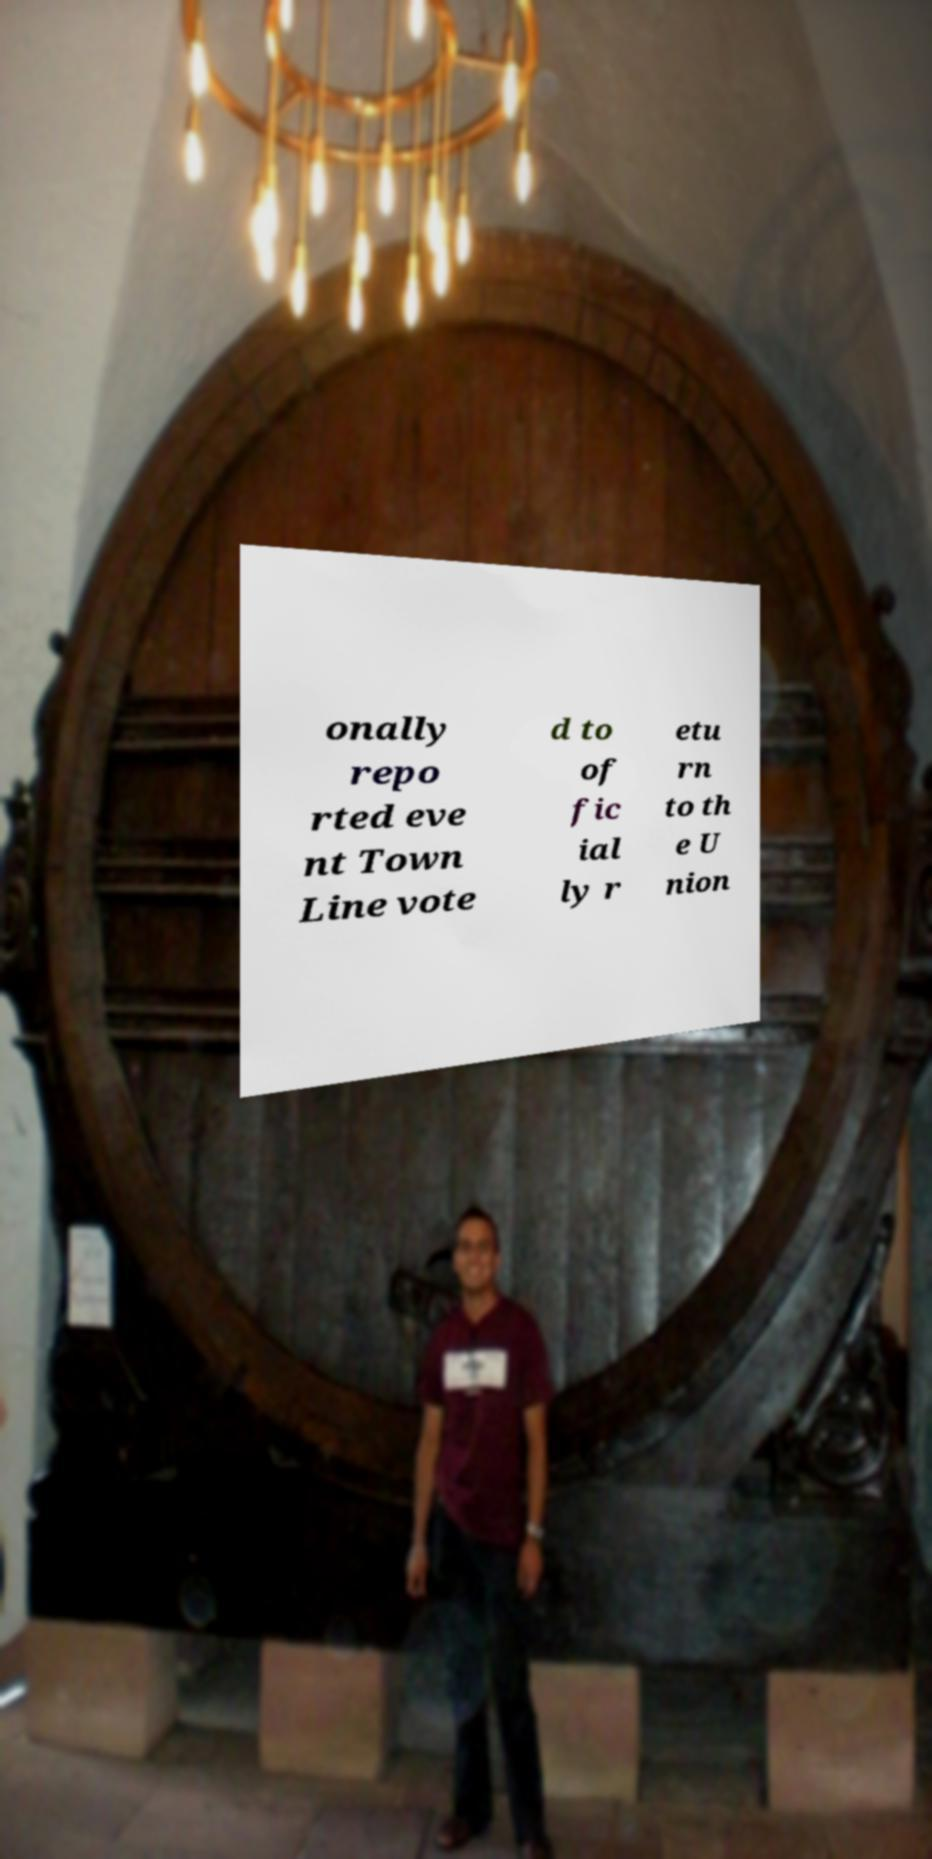What messages or text are displayed in this image? I need them in a readable, typed format. onally repo rted eve nt Town Line vote d to of fic ial ly r etu rn to th e U nion 